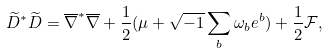Convert formula to latex. <formula><loc_0><loc_0><loc_500><loc_500>\widetilde { D } ^ { \ast } \widetilde { D } = \overline { \nabla } ^ { \ast } \overline { \nabla } + \frac { 1 } { 2 } ( \mu + \sqrt { - 1 } \sum _ { b } \omega _ { b } e ^ { b } ) + \frac { 1 } { 2 } \mathcal { F } ,</formula> 